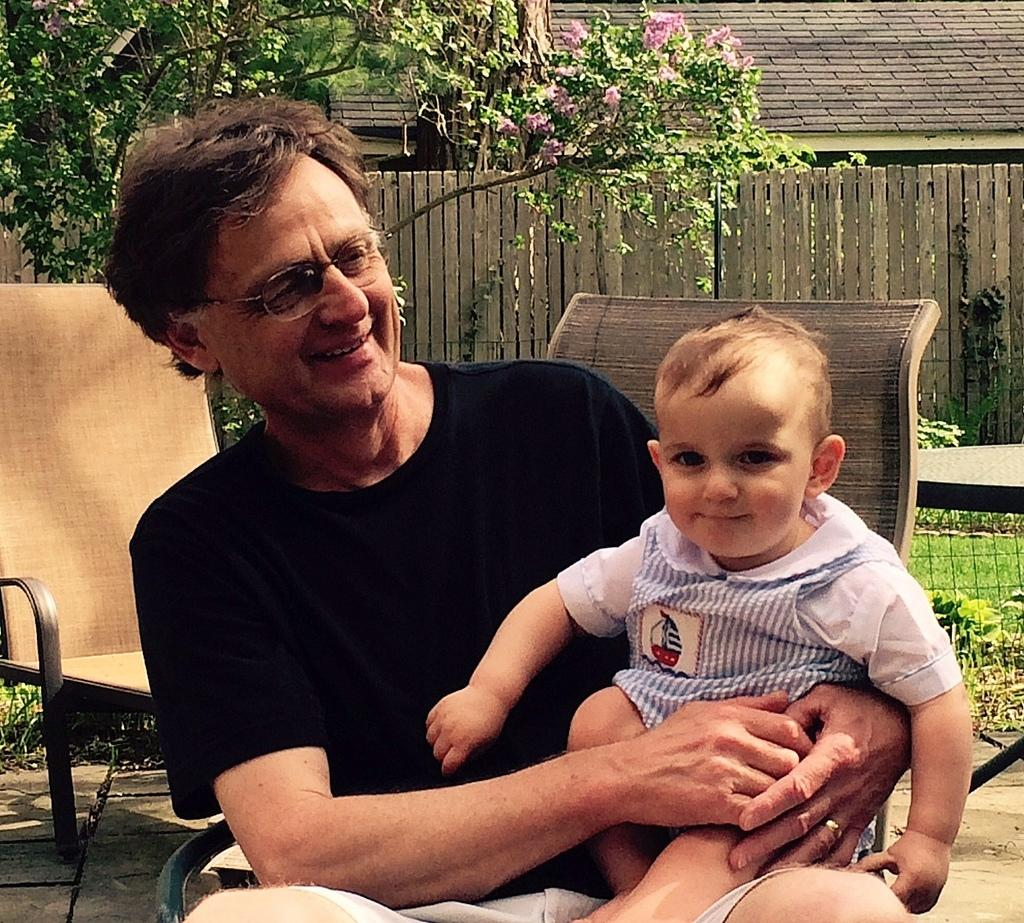What is the person in the image wearing? The person is wearing a black shirt in the image. What is the person doing in the image? The person is sitting and holding a kid in his hands. What can be seen in the background of the image? There are chairs, trees, a wooden wall, and a building in the background of the image. What is the weight of the hall in the image? There is no hall present in the image, so it is not possible to determine its weight. 